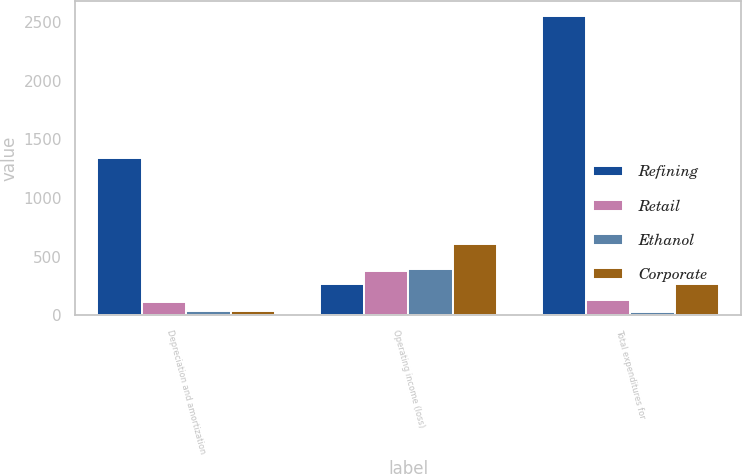Convert chart to OTSL. <chart><loc_0><loc_0><loc_500><loc_500><stacked_bar_chart><ecel><fcel>Depreciation and amortization<fcel>Operating income (loss)<fcel>Total expenditures for<nl><fcel>Refining<fcel>1338<fcel>265<fcel>2556<nl><fcel>Retail<fcel>115<fcel>381<fcel>134<nl><fcel>Ethanol<fcel>39<fcel>396<fcel>32<nl><fcel>Corporate<fcel>42<fcel>613<fcel>265<nl></chart> 